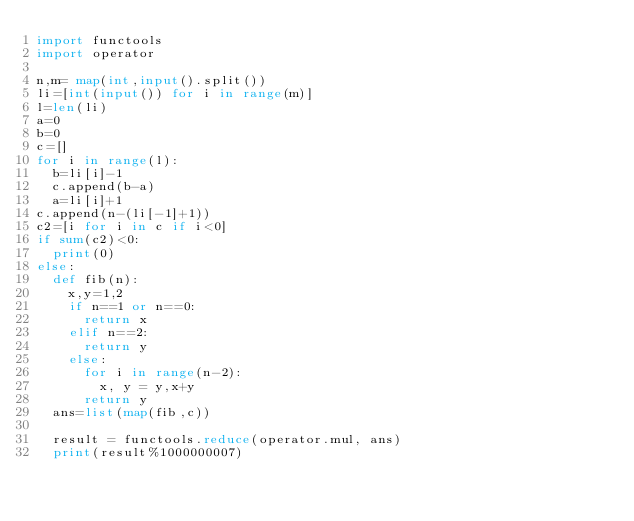<code> <loc_0><loc_0><loc_500><loc_500><_Python_>import functools
import operator

n,m= map(int,input().split())
li=[int(input()) for i in range(m)]
l=len(li)
a=0
b=0
c=[]
for i in range(l):
  b=li[i]-1
  c.append(b-a)
  a=li[i]+1
c.append(n-(li[-1]+1))
c2=[i for i in c if i<0]
if sum(c2)<0:
  print(0)
else:
  def fib(n):
    x,y=1,2
    if n==1 or n==0:
      return x
    elif n==2:
      return y
    else:
      for i in range(n-2):
        x, y = y,x+y
      return y
  ans=list(map(fib,c))

  result = functools.reduce(operator.mul, ans)
  print(result%1000000007)</code> 